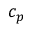<formula> <loc_0><loc_0><loc_500><loc_500>c _ { p }</formula> 